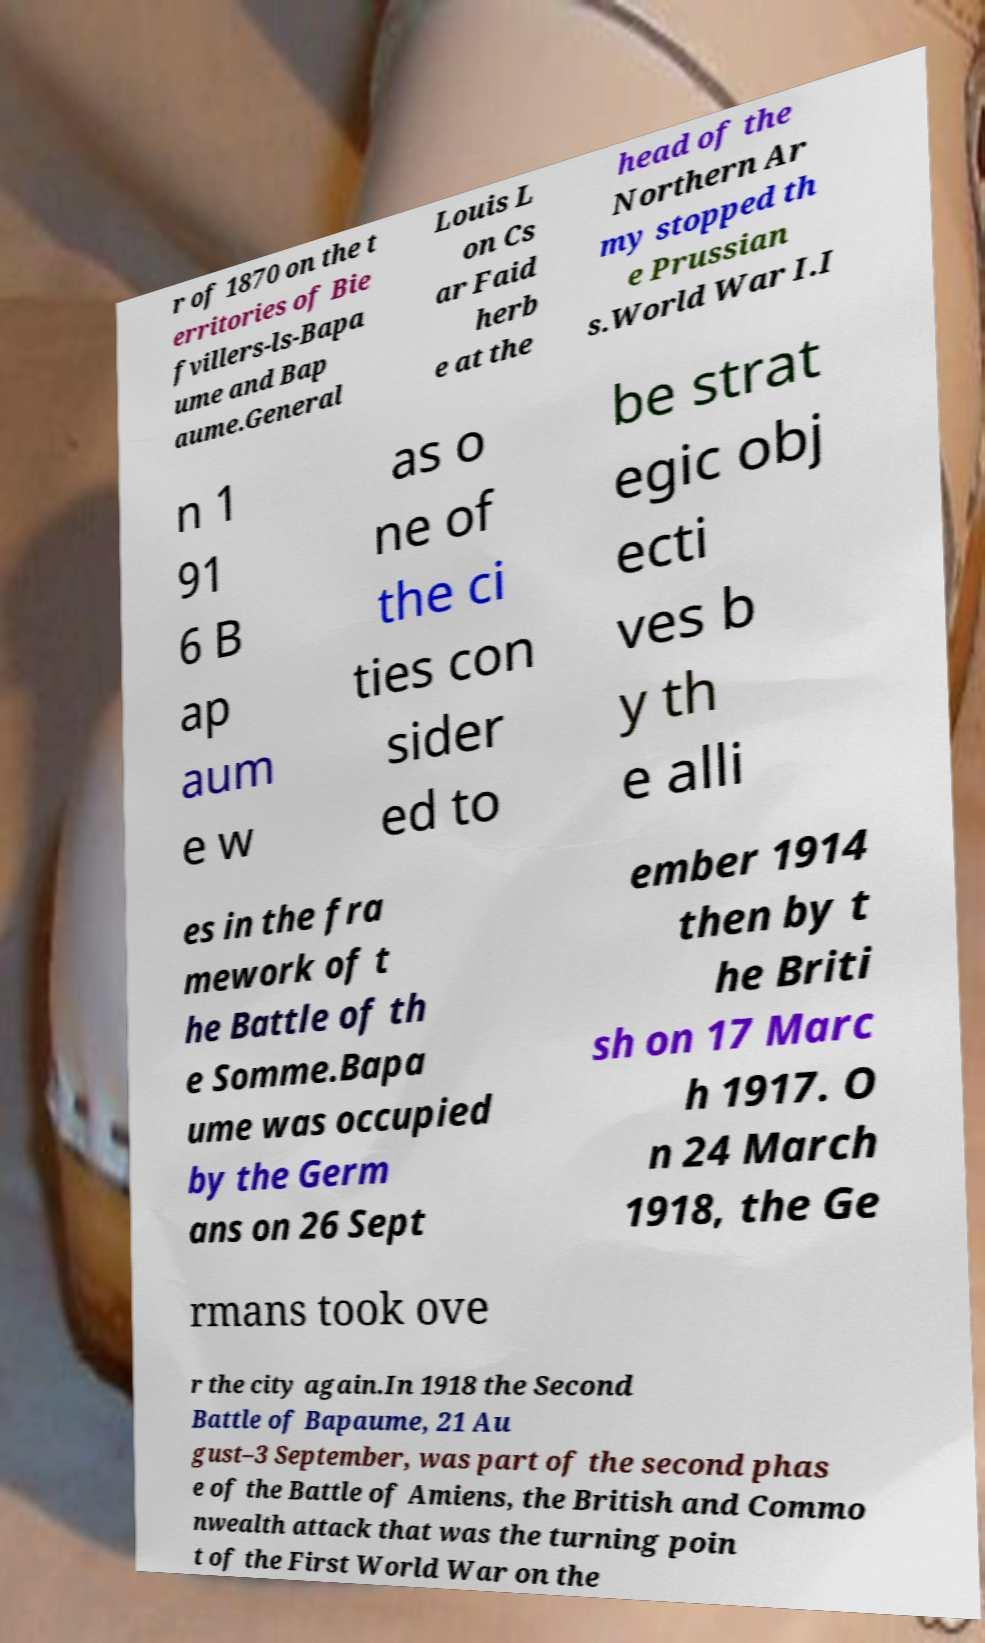Can you accurately transcribe the text from the provided image for me? r of 1870 on the t erritories of Bie fvillers-ls-Bapa ume and Bap aume.General Louis L on Cs ar Faid herb e at the head of the Northern Ar my stopped th e Prussian s.World War I.I n 1 91 6 B ap aum e w as o ne of the ci ties con sider ed to be strat egic obj ecti ves b y th e alli es in the fra mework of t he Battle of th e Somme.Bapa ume was occupied by the Germ ans on 26 Sept ember 1914 then by t he Briti sh on 17 Marc h 1917. O n 24 March 1918, the Ge rmans took ove r the city again.In 1918 the Second Battle of Bapaume, 21 Au gust–3 September, was part of the second phas e of the Battle of Amiens, the British and Commo nwealth attack that was the turning poin t of the First World War on the 